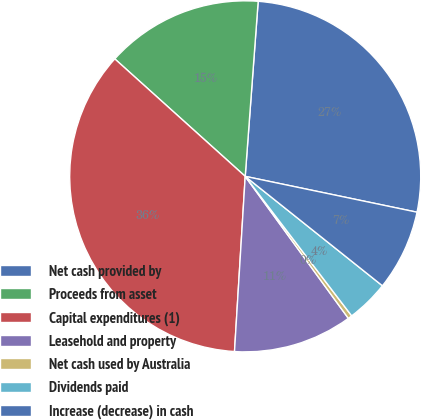Convert chart to OTSL. <chart><loc_0><loc_0><loc_500><loc_500><pie_chart><fcel>Net cash provided by<fcel>Proceeds from asset<fcel>Capital expenditures (1)<fcel>Leasehold and property<fcel>Net cash used by Australia<fcel>Dividends paid<fcel>Increase (decrease) in cash<nl><fcel>27.1%<fcel>14.51%<fcel>35.7%<fcel>10.97%<fcel>0.38%<fcel>3.91%<fcel>7.44%<nl></chart> 